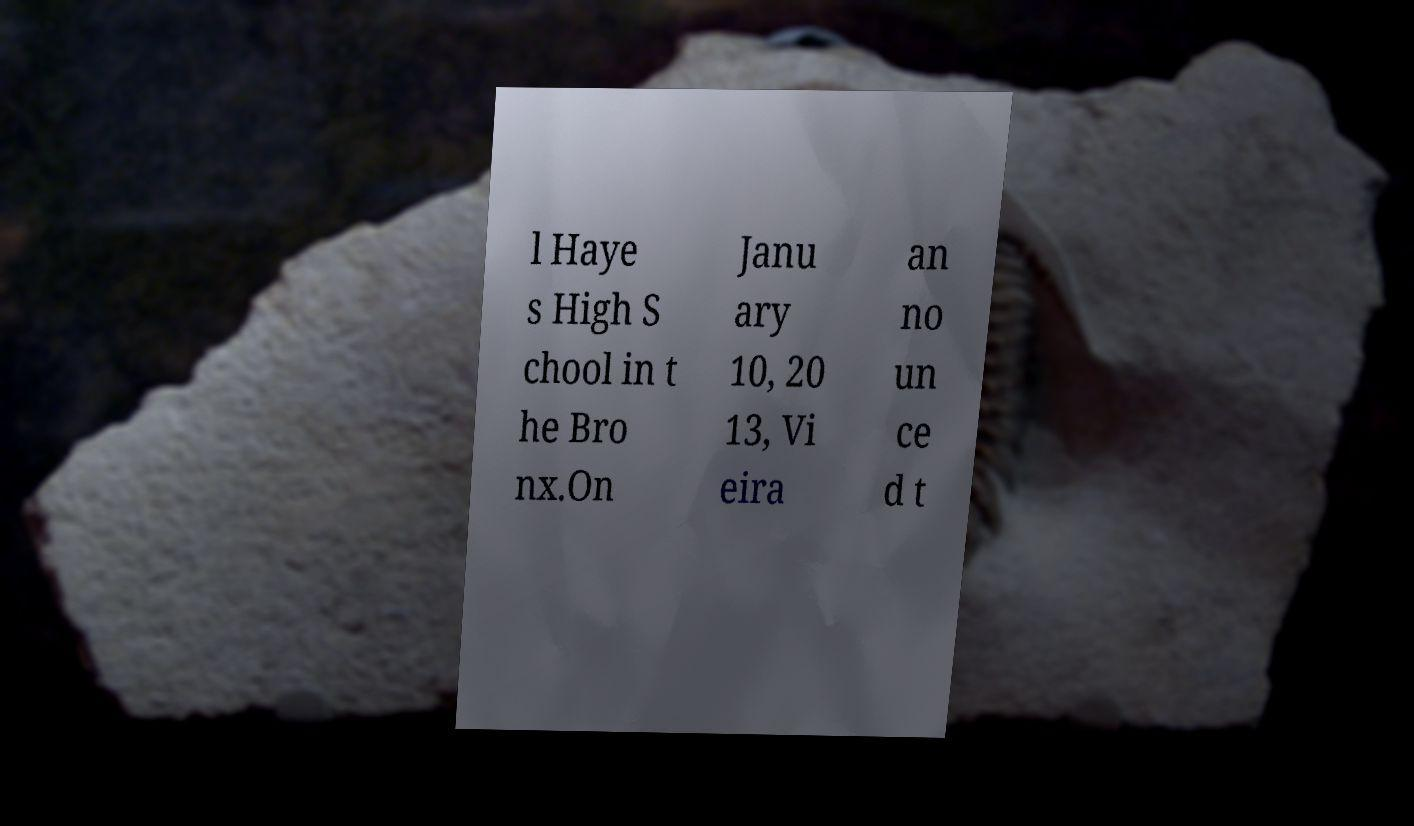What messages or text are displayed in this image? I need them in a readable, typed format. l Haye s High S chool in t he Bro nx.On Janu ary 10, 20 13, Vi eira an no un ce d t 